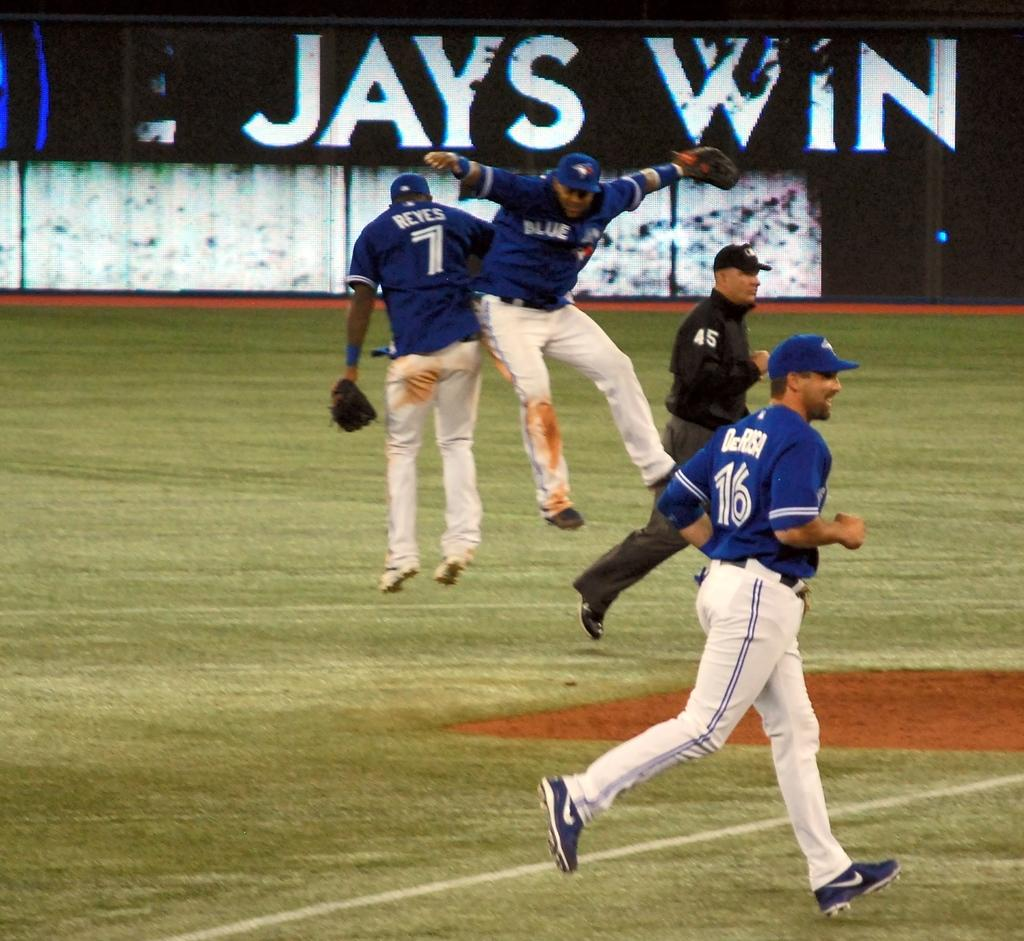<image>
Share a concise interpretation of the image provided. baseplayers 7 and 16 in front of a jays win banner 